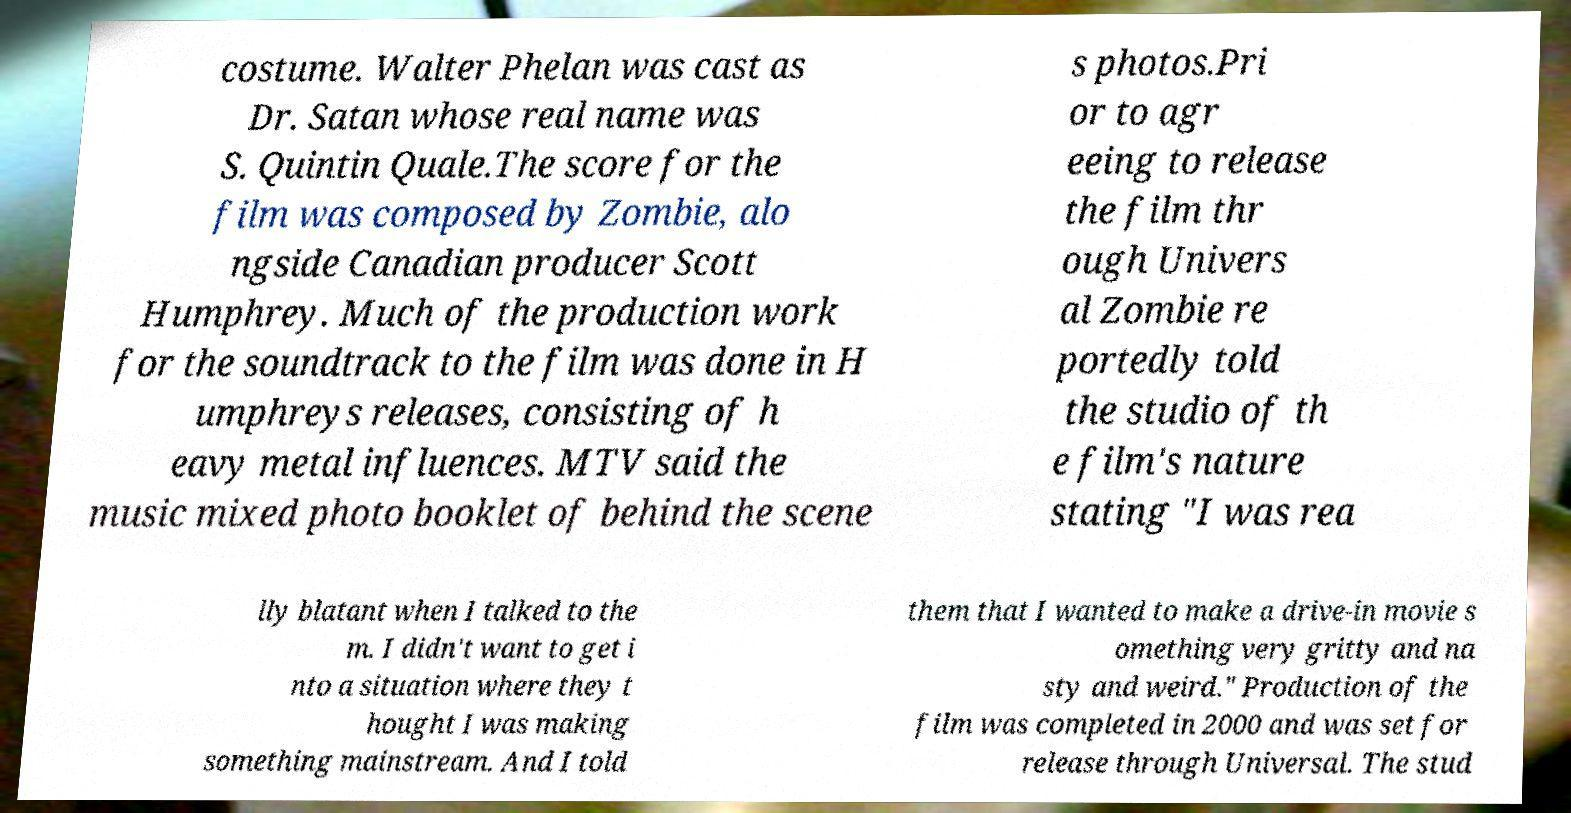Could you extract and type out the text from this image? costume. Walter Phelan was cast as Dr. Satan whose real name was S. Quintin Quale.The score for the film was composed by Zombie, alo ngside Canadian producer Scott Humphrey. Much of the production work for the soundtrack to the film was done in H umphreys releases, consisting of h eavy metal influences. MTV said the music mixed photo booklet of behind the scene s photos.Pri or to agr eeing to release the film thr ough Univers al Zombie re portedly told the studio of th e film's nature stating "I was rea lly blatant when I talked to the m. I didn't want to get i nto a situation where they t hought I was making something mainstream. And I told them that I wanted to make a drive-in movie s omething very gritty and na sty and weird." Production of the film was completed in 2000 and was set for release through Universal. The stud 